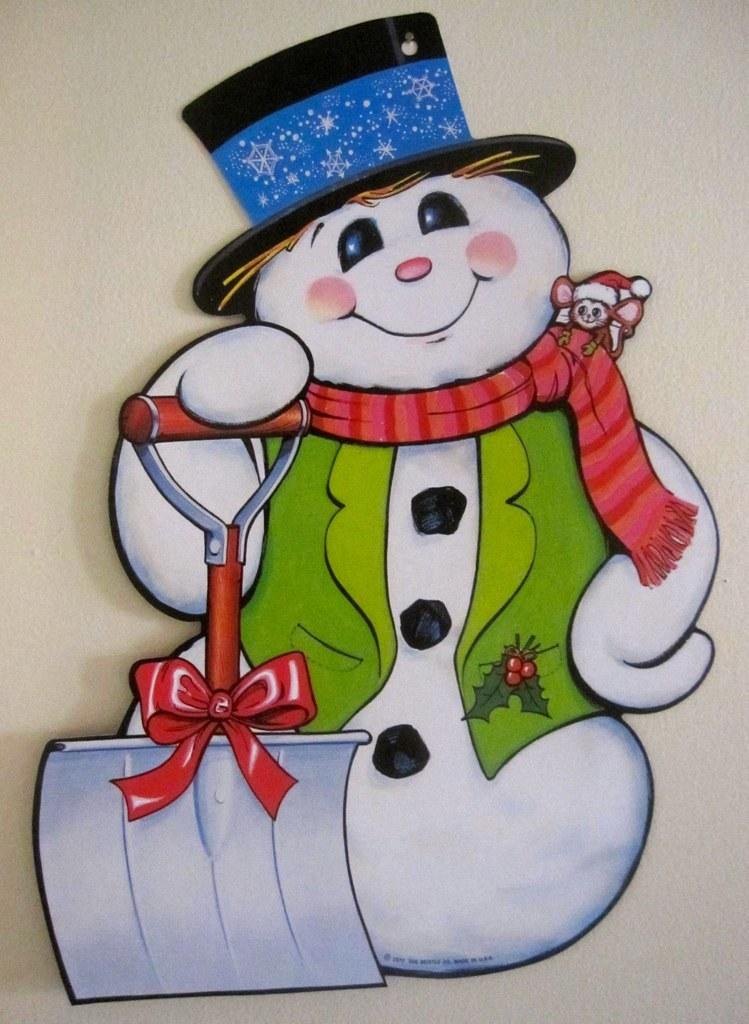What is the main subject of the image? There is a picture of a snowman in the image. How many accounts does the snowman have in the image? There are no accounts mentioned or depicted in the image, as it features a picture of a snowman. 